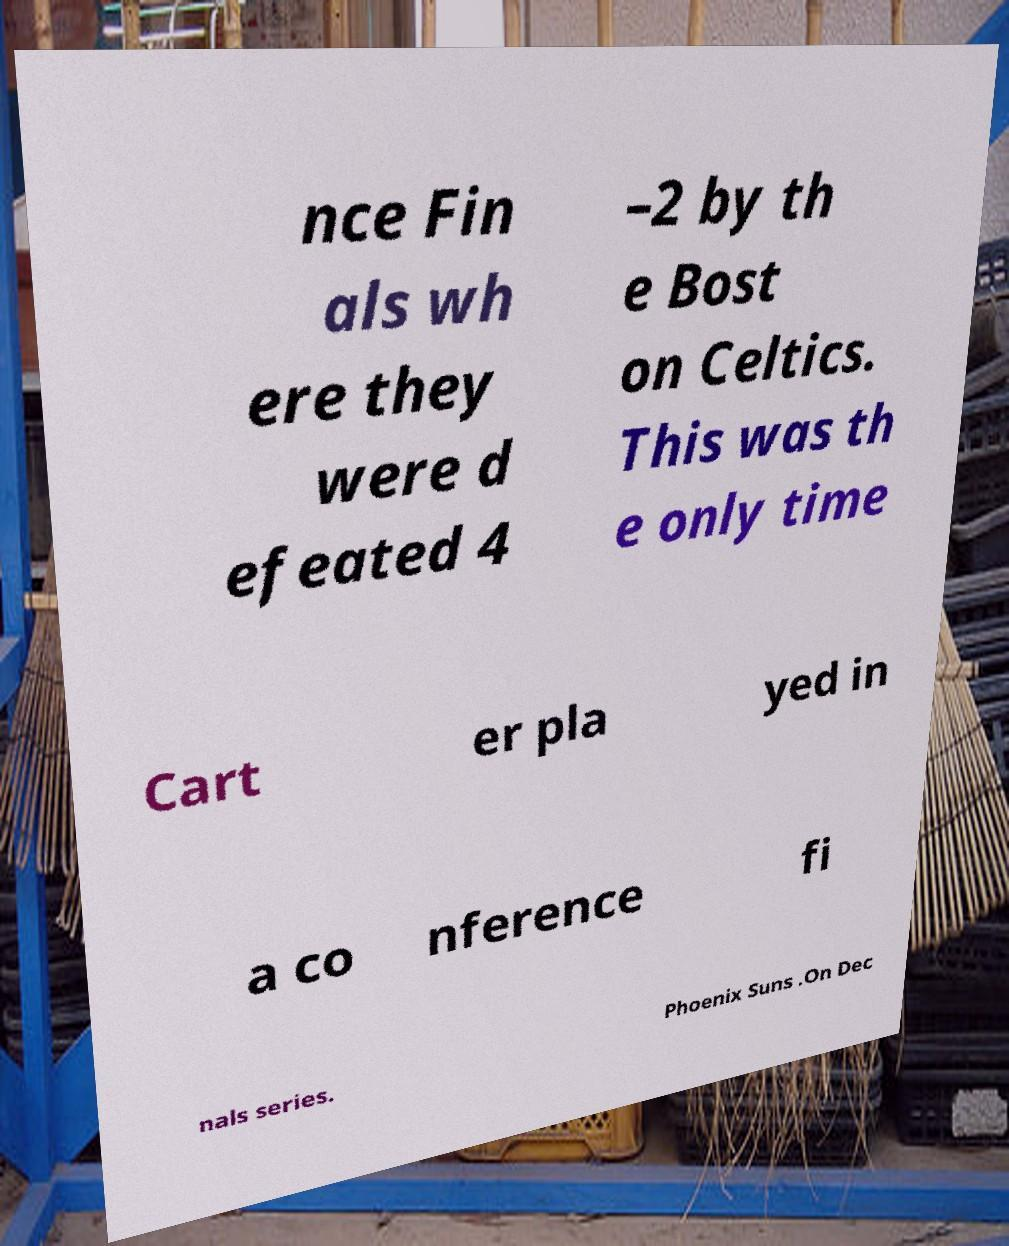Could you extract and type out the text from this image? nce Fin als wh ere they were d efeated 4 –2 by th e Bost on Celtics. This was th e only time Cart er pla yed in a co nference fi nals series. Phoenix Suns .On Dec 